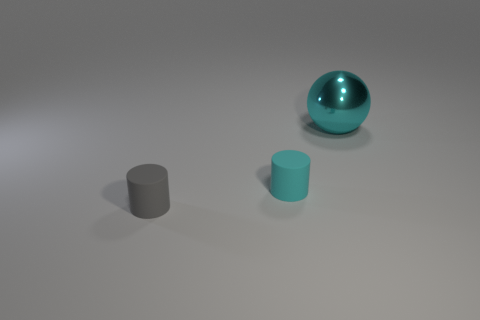Add 2 small rubber cylinders. How many objects exist? 5 Subtract all spheres. How many objects are left? 2 Subtract all small gray matte objects. Subtract all cylinders. How many objects are left? 0 Add 1 tiny cyan cylinders. How many tiny cyan cylinders are left? 2 Add 1 big brown spheres. How many big brown spheres exist? 1 Subtract 0 brown blocks. How many objects are left? 3 